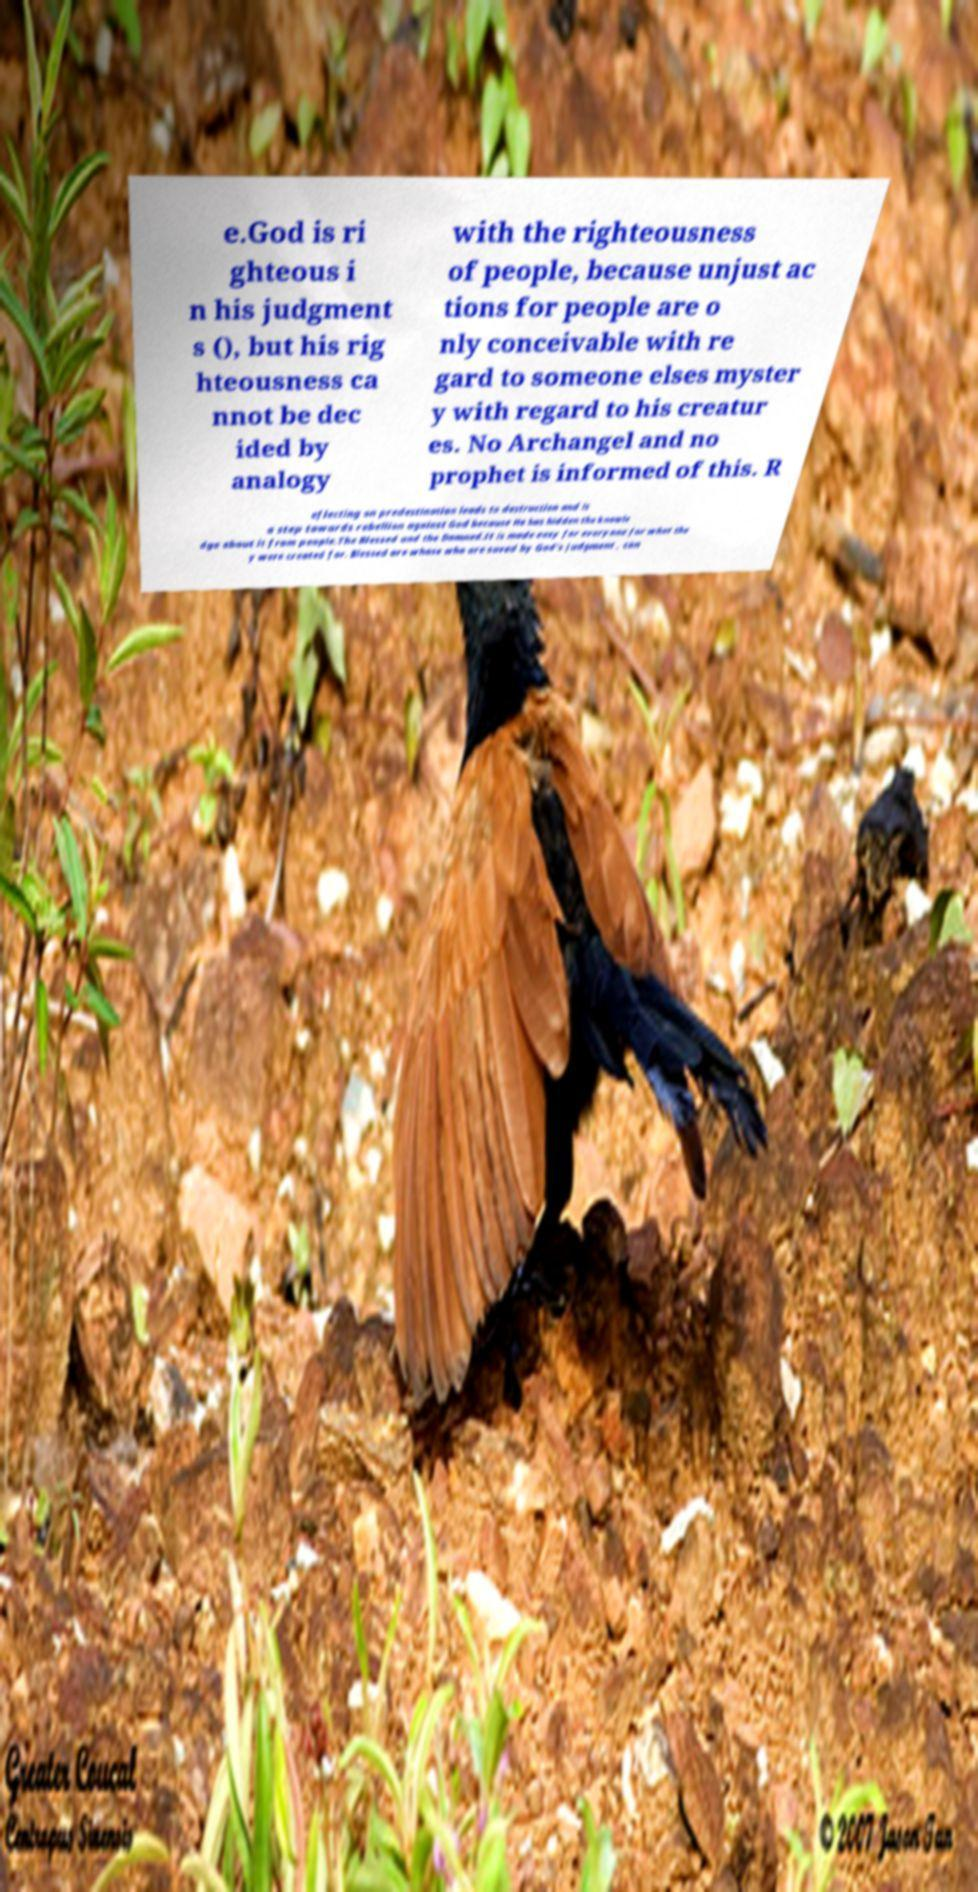There's text embedded in this image that I need extracted. Can you transcribe it verbatim? e.God is ri ghteous i n his judgment s (), but his rig hteousness ca nnot be dec ided by analogy with the righteousness of people, because unjust ac tions for people are o nly conceivable with re gard to someone elses myster y with regard to his creatur es. No Archangel and no prophet is informed of this. R eflecting on predestination leads to destruction and is a step towards rebellion against God because He has hidden the knowle dge about it from people.The Blessed and the Damned.It is made easy for everyone for what the y were created for. Blessed are whose who are saved by God's judgment , con 